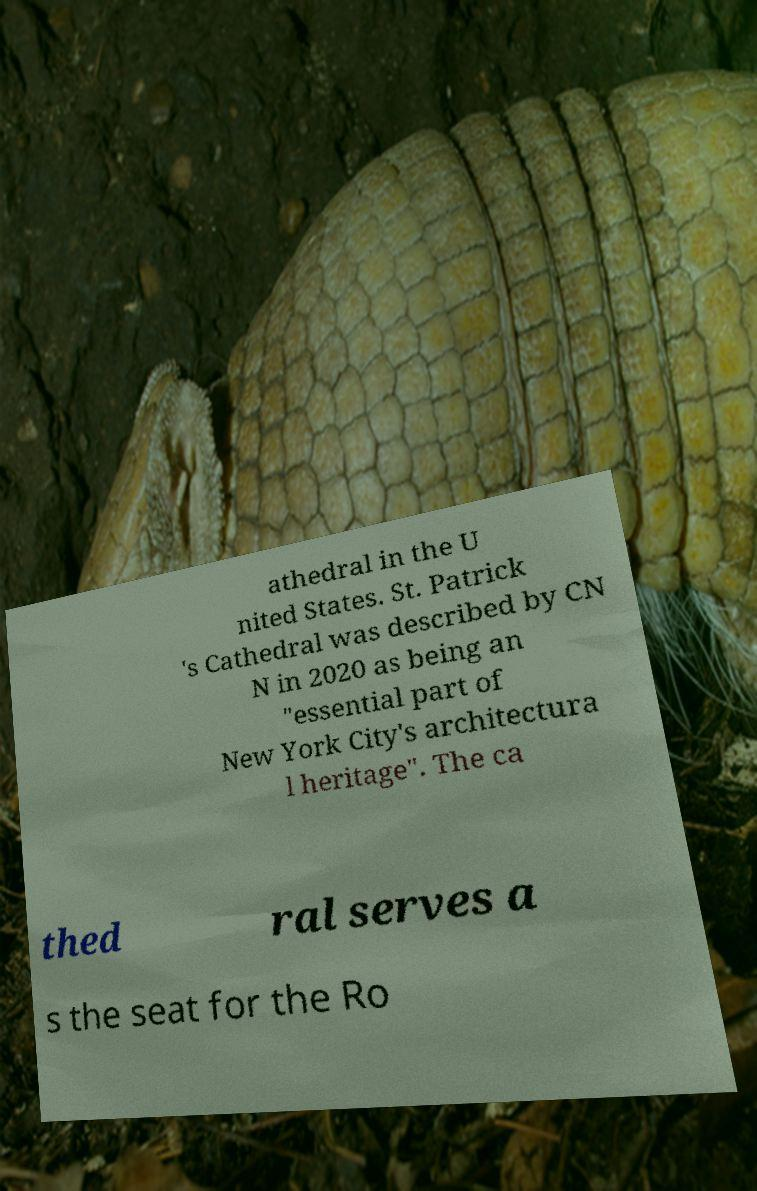Could you extract and type out the text from this image? athedral in the U nited States. St. Patrick 's Cathedral was described by CN N in 2020 as being an "essential part of New York City's architectura l heritage". The ca thed ral serves a s the seat for the Ro 